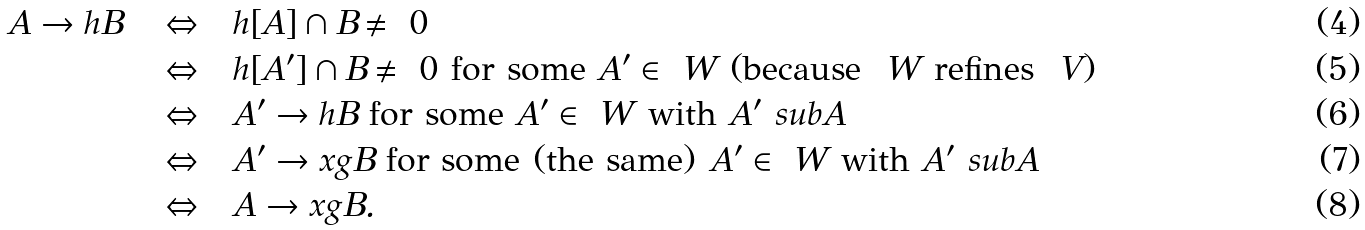<formula> <loc_0><loc_0><loc_500><loc_500>A \to h B \quad \Leftrightarrow & \quad h [ A ] \cap B \neq \ 0 \\ \Leftrightarrow & \quad h [ A ^ { \prime } ] \cap B \neq \ 0 \text { for some } A ^ { \prime } \in \ W \ ( \text {because } \ W \text { refines } \ V ) \\ \Leftrightarrow & \quad A ^ { \prime } \to h B \text { for some } A ^ { \prime } \in \ W \text { with } A ^ { \prime } \ s u b A \\ \Leftrightarrow & \quad A ^ { \prime } \to x { g } B \text { for some (the same) } A ^ { \prime } \in \ W \text { with } A ^ { \prime } \ s u b A \\ \Leftrightarrow & \quad A \to x { g } B .</formula> 